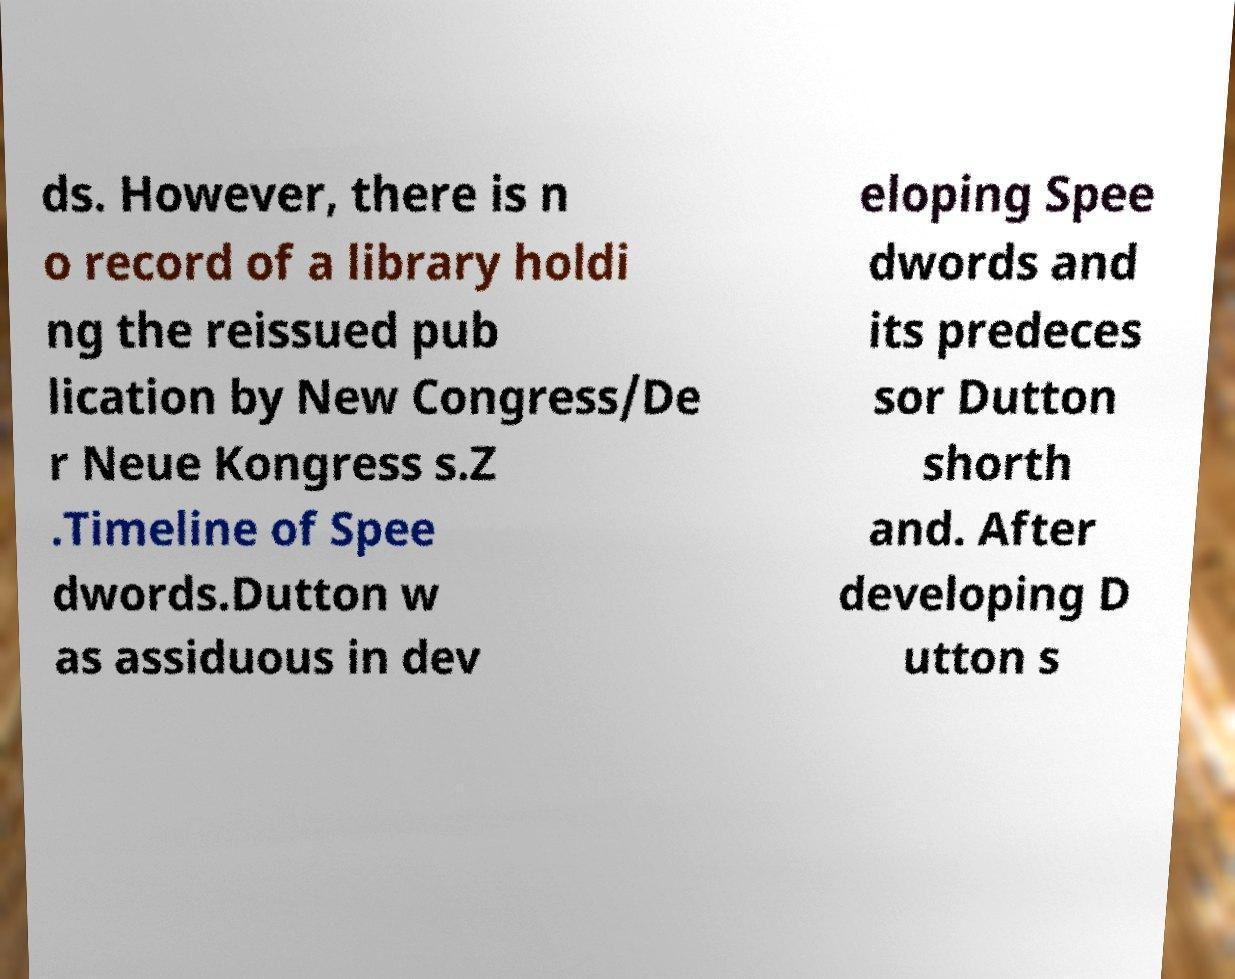Can you read and provide the text displayed in the image?This photo seems to have some interesting text. Can you extract and type it out for me? ds. However, there is n o record of a library holdi ng the reissued pub lication by New Congress/De r Neue Kongress s.Z .Timeline of Spee dwords.Dutton w as assiduous in dev eloping Spee dwords and its predeces sor Dutton shorth and. After developing D utton s 